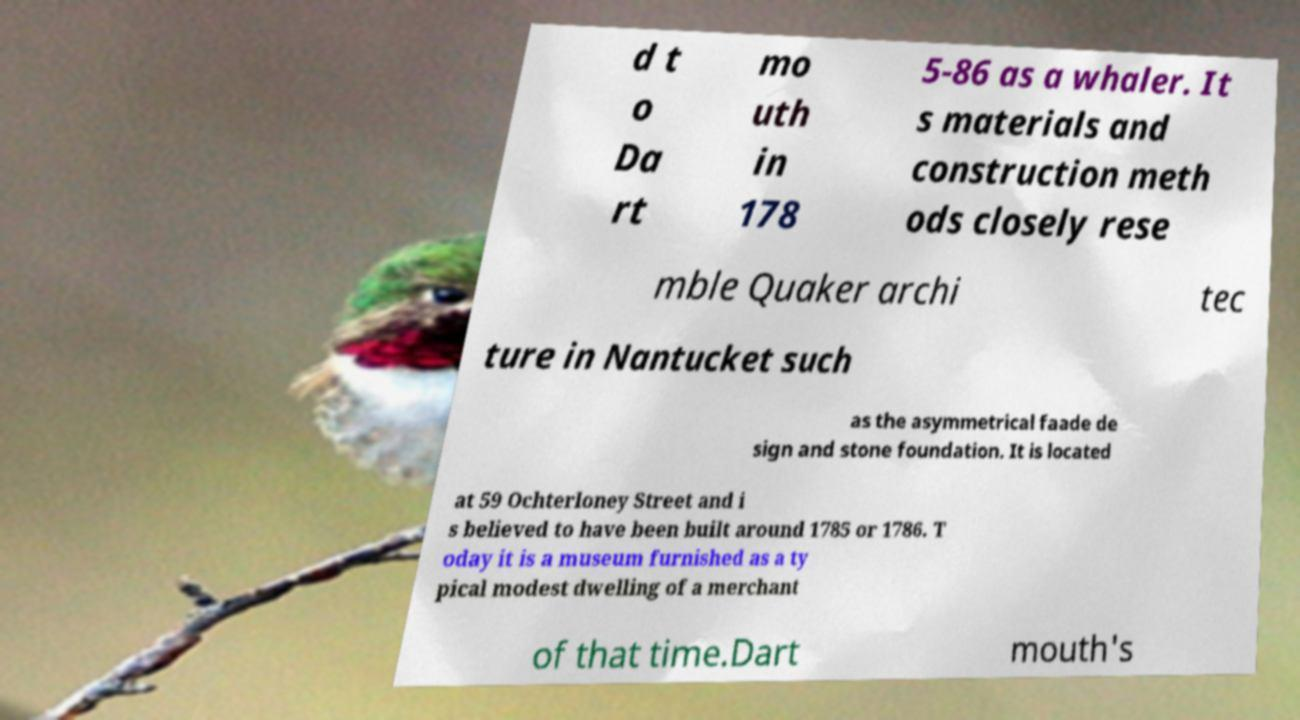Could you assist in decoding the text presented in this image and type it out clearly? d t o Da rt mo uth in 178 5-86 as a whaler. It s materials and construction meth ods closely rese mble Quaker archi tec ture in Nantucket such as the asymmetrical faade de sign and stone foundation. It is located at 59 Ochterloney Street and i s believed to have been built around 1785 or 1786. T oday it is a museum furnished as a ty pical modest dwelling of a merchant of that time.Dart mouth's 